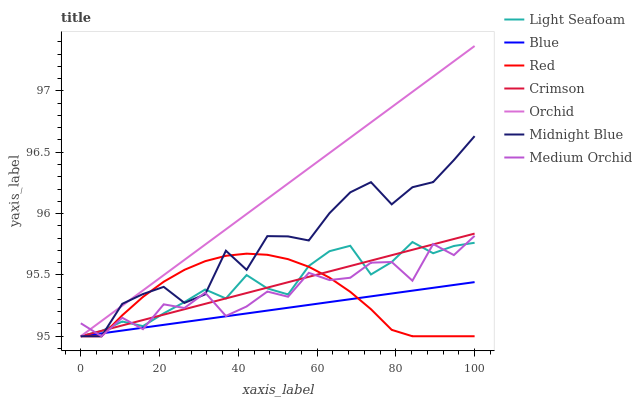Does Midnight Blue have the minimum area under the curve?
Answer yes or no. No. Does Midnight Blue have the maximum area under the curve?
Answer yes or no. No. Is Midnight Blue the smoothest?
Answer yes or no. No. Is Midnight Blue the roughest?
Answer yes or no. No. Does Midnight Blue have the highest value?
Answer yes or no. No. 